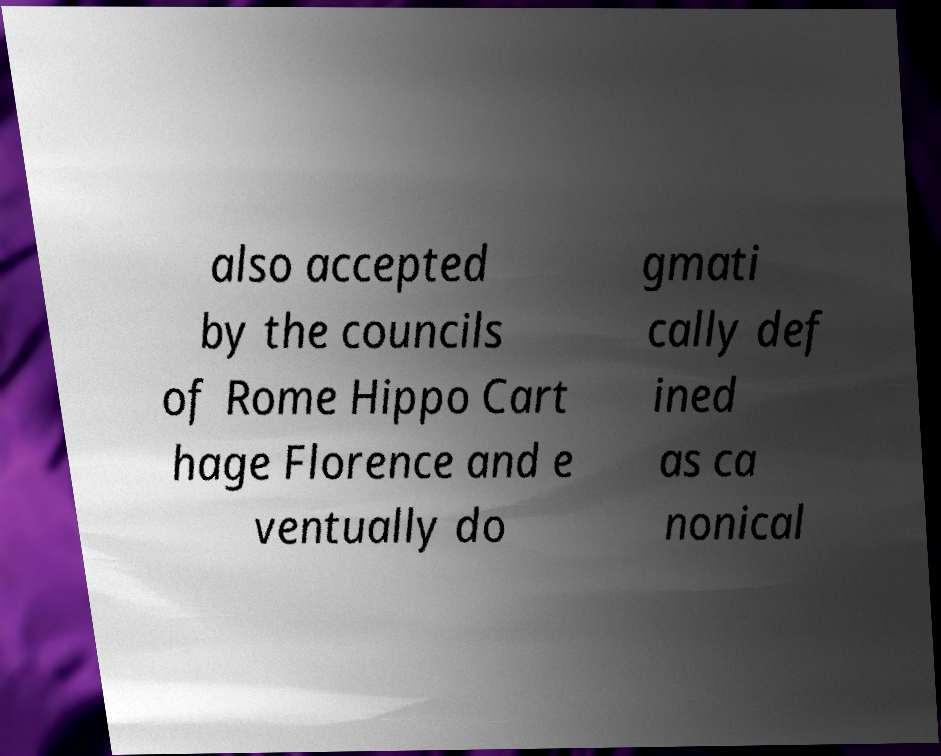I need the written content from this picture converted into text. Can you do that? also accepted by the councils of Rome Hippo Cart hage Florence and e ventually do gmati cally def ined as ca nonical 